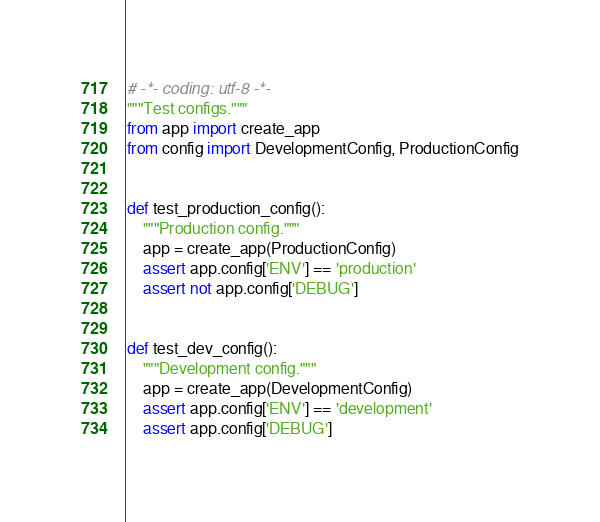Convert code to text. <code><loc_0><loc_0><loc_500><loc_500><_Python_># -*- coding: utf-8 -*-
"""Test configs."""
from app import create_app
from config import DevelopmentConfig, ProductionConfig


def test_production_config():
    """Production config."""
    app = create_app(ProductionConfig)
    assert app.config['ENV'] == 'production'
    assert not app.config['DEBUG']


def test_dev_config():
    """Development config."""
    app = create_app(DevelopmentConfig)
    assert app.config['ENV'] == 'development'
    assert app.config['DEBUG']
</code> 